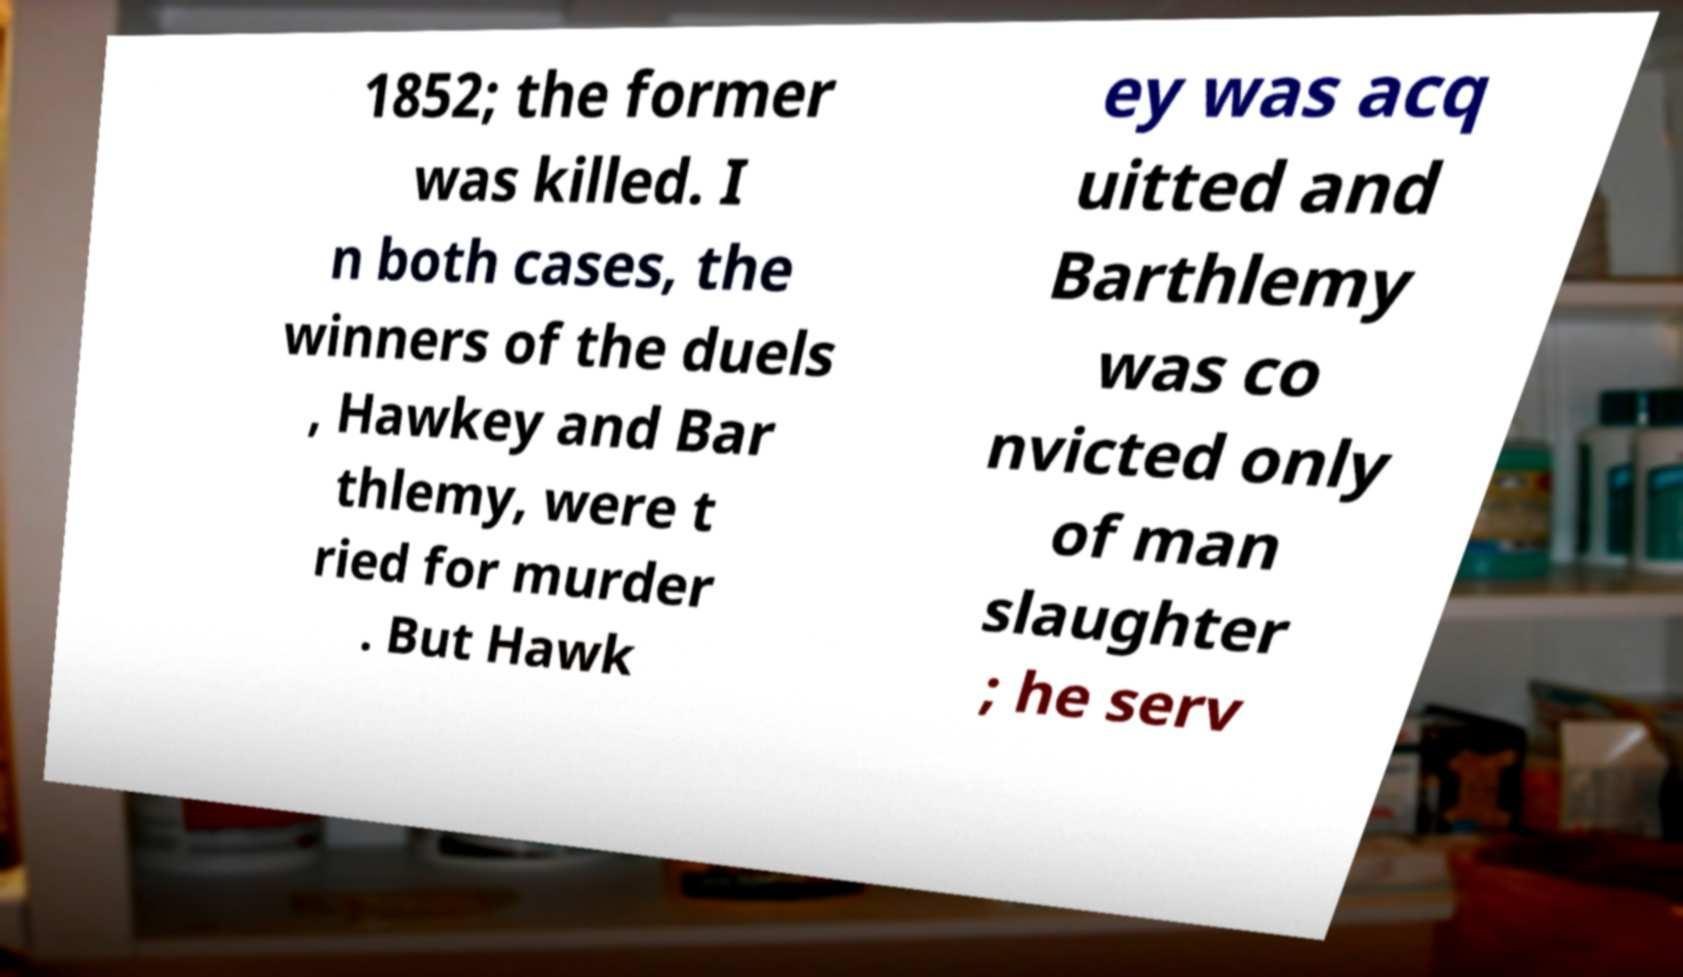For documentation purposes, I need the text within this image transcribed. Could you provide that? 1852; the former was killed. I n both cases, the winners of the duels , Hawkey and Bar thlemy, were t ried for murder . But Hawk ey was acq uitted and Barthlemy was co nvicted only of man slaughter ; he serv 